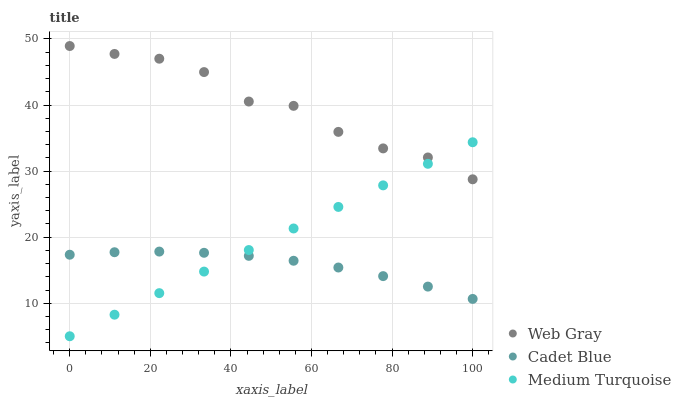Does Cadet Blue have the minimum area under the curve?
Answer yes or no. Yes. Does Web Gray have the maximum area under the curve?
Answer yes or no. Yes. Does Medium Turquoise have the minimum area under the curve?
Answer yes or no. No. Does Medium Turquoise have the maximum area under the curve?
Answer yes or no. No. Is Medium Turquoise the smoothest?
Answer yes or no. Yes. Is Web Gray the roughest?
Answer yes or no. Yes. Is Web Gray the smoothest?
Answer yes or no. No. Is Medium Turquoise the roughest?
Answer yes or no. No. Does Medium Turquoise have the lowest value?
Answer yes or no. Yes. Does Web Gray have the lowest value?
Answer yes or no. No. Does Web Gray have the highest value?
Answer yes or no. Yes. Does Medium Turquoise have the highest value?
Answer yes or no. No. Is Cadet Blue less than Web Gray?
Answer yes or no. Yes. Is Web Gray greater than Cadet Blue?
Answer yes or no. Yes. Does Medium Turquoise intersect Web Gray?
Answer yes or no. Yes. Is Medium Turquoise less than Web Gray?
Answer yes or no. No. Is Medium Turquoise greater than Web Gray?
Answer yes or no. No. Does Cadet Blue intersect Web Gray?
Answer yes or no. No. 